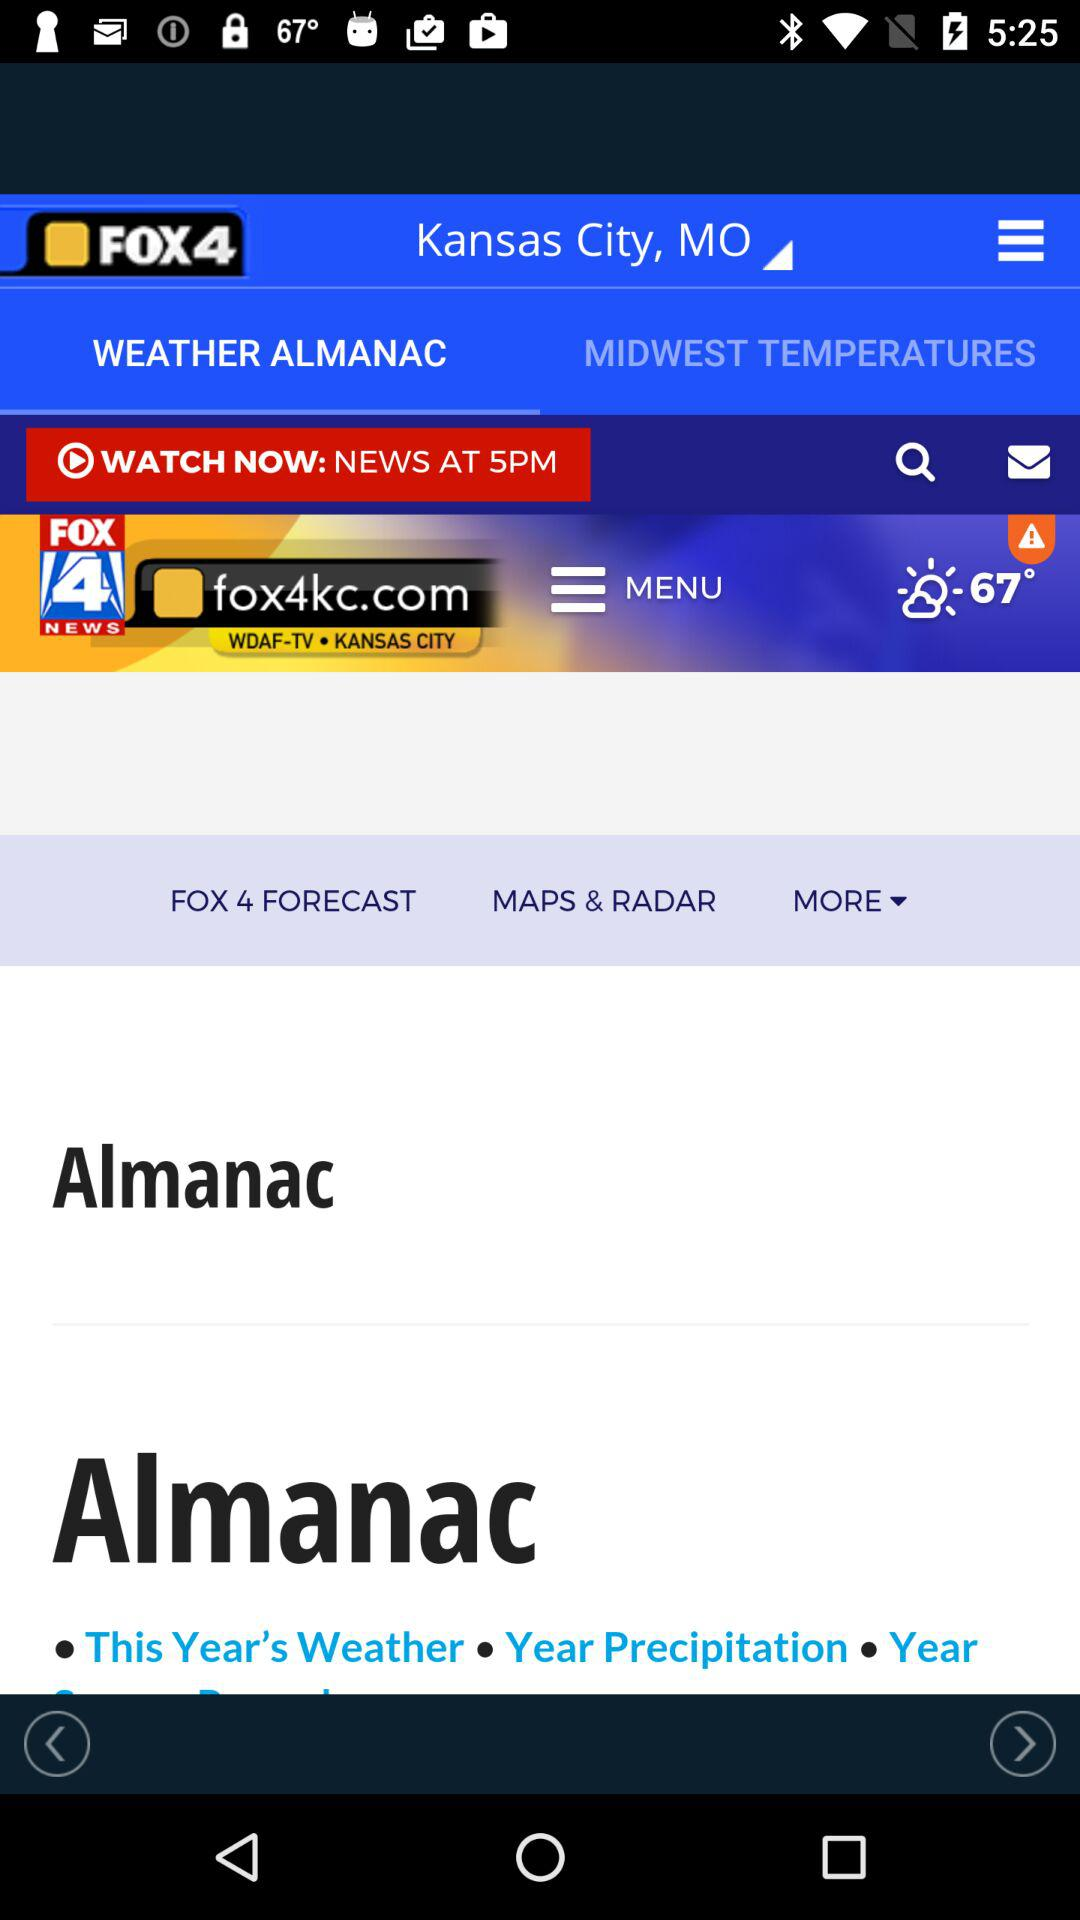For which city is the weather news posted? The weather news is posted for Kanas City. 